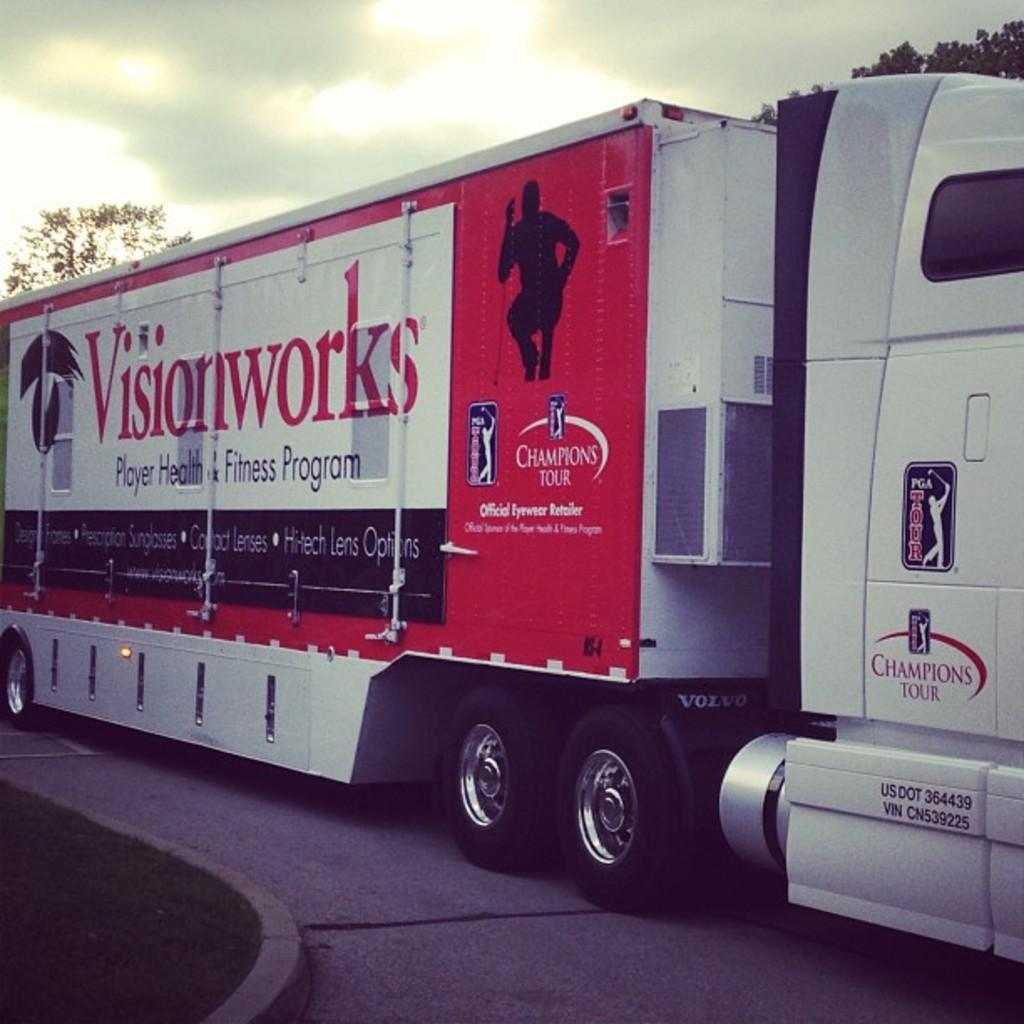Can you describe this image briefly? In this image I can see a vehicle which is in white and red color. Background I can see trees in green color and the sky is in white color. 